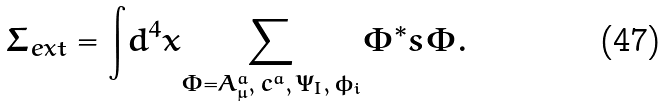Convert formula to latex. <formula><loc_0><loc_0><loc_500><loc_500>\Sigma _ { e x t } = { \int } d ^ { 4 } x { \sum _ { \Phi = A _ { \mu } ^ { a } , \, c ^ { a } , \, \Psi _ { I } , \, \phi _ { i } } } \Phi ^ { * } s \Phi .</formula> 